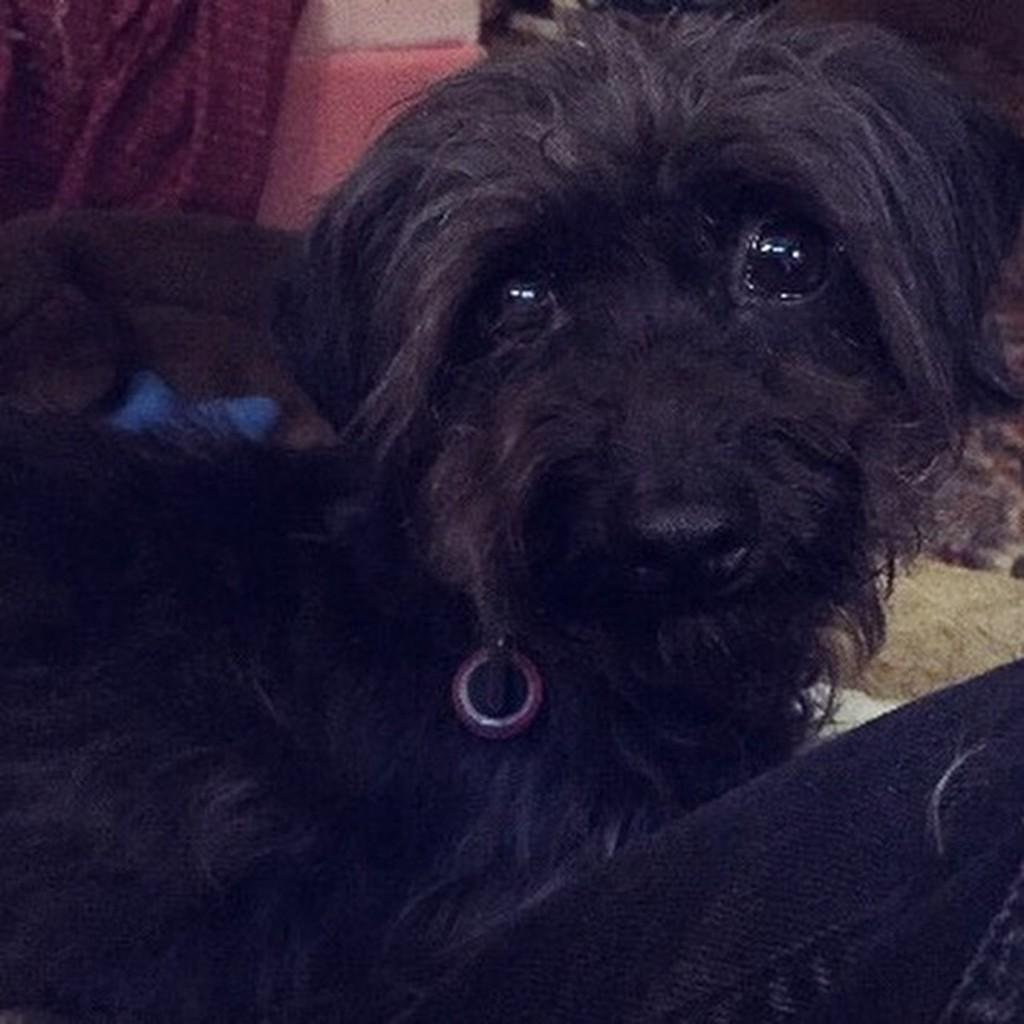What type of animal is in the image? There is a black color dog in the image. What can be seen on the right side of the image? There is an object on the right side of the image. What is present in the background of the image? There is a cloth and an object in the background of the image. What type of government is depicted in the image? There is no depiction of a government in the image; it features a black color dog and various objects. What type of coat is the dog wearing in the image? The dog is not wearing a coat in the image; it is a black color dog with no additional clothing. 